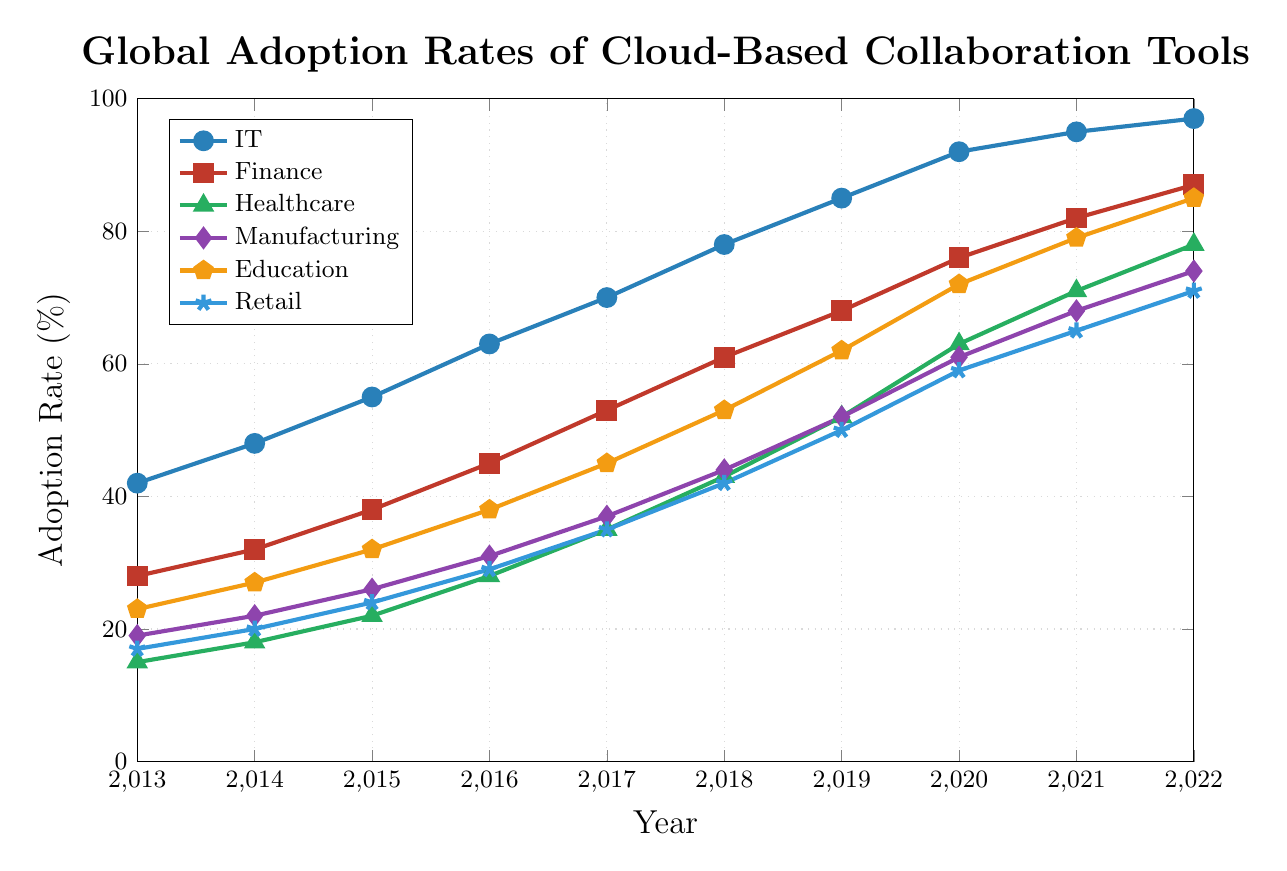How did the adoption rate in the Healthcare sector change from 2013 to 2017? The adoption rate in the Healthcare sector in 2013 was 15%, and in 2017 it was 35%. The change can be calculated by subtracting the adoption rate in 2013 from the adoption rate in 2017: 35% - 15% = 20%.
Answer: 20% Which industry had the highest adoption rate in 2022? The adoption rates in 2022 for each industry are:
- IT: 97%
- Finance: 87%
- Healthcare: 78%
- Manufacturing: 74%
- Education: 85%
- Retail: 71%
The highest adoption rate is in the IT industry, which has 97%.
Answer: IT What is the combined adoption rate of Education and Retail sectors in 2020? The adoption rate in 2020 for the Education sector is 72%, and for the Retail sector, it is 59%. The combined adoption rate is calculated by summing these two rates: 72% + 59% = 131%.
Answer: 131% Which sector saw the largest increase in adoption between 2017 and 2020? The increases in adoption rates between 2017 and 2020 for each sector are:
- IT: 92% - 70% = 22%
- Finance: 76% - 53% = 23%
- Healthcare: 63% - 35% = 28%
- Manufacturing: 61% - 37% = 24%
- Education: 72% - 45% = 27%
- Retail: 59% - 35% = 24%
The largest increase is in the Healthcare sector, with a rise of 28%.
Answer: Healthcare Compare the adoption rate of the Manufacturing sector in 2016 with that of the Retail sector in 2019. Which one was higher? The adoption rate of the Manufacturing sector in 2016 is 31%, and the adoption rate of the Retail sector in 2019 is 50%. Comparing these two rates, 50% is higher than 31%.
Answer: Retail sector in 2019 What is the average adoption rate of the IT sector from 2013 to 2022? To calculate the average adoption rate of the IT sector over the 10 years, sum the adoption rates and divide by the number of years: 
(42% + 48% + 55% + 63% + 70% + 78% + 85% + 92% + 95% + 97%) / 10 = (725%) / 10 = 72.5%.
Answer: 72.5% Which sector had the steadiest growth in adoption rates from 2013 to 2022? To determine the sector with the steadiest growth, visually inspect the plots. The IT sector shows consistently high growth without drastic jumps from year to year, indicating steady growth.
Answer: IT In what year did the Finance sector adoption rate surpass 50%? Observing the plot, the adoption rate in the Finance sector surpassed 50% in 2017, where it reached 53%.
Answer: 2017 